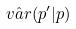<formula> <loc_0><loc_0><loc_500><loc_500>\hat { v a r } ( p ^ { \prime } | p )</formula> 